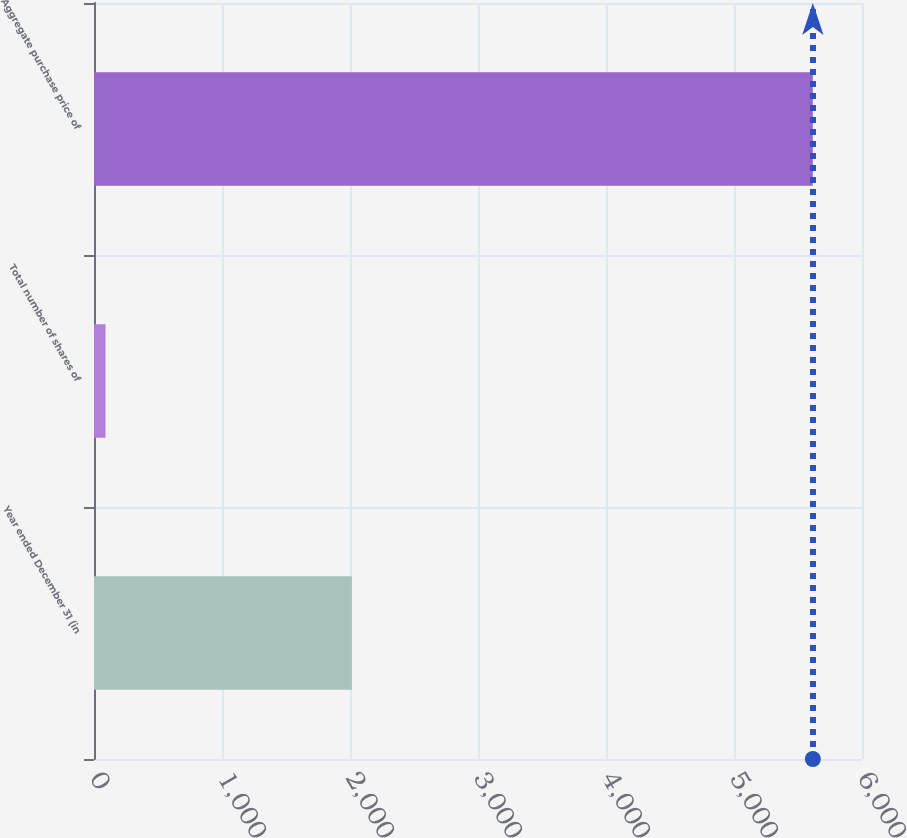Convert chart to OTSL. <chart><loc_0><loc_0><loc_500><loc_500><bar_chart><fcel>Year ended December 31 (in<fcel>Total number of shares of<fcel>Aggregate purchase price of<nl><fcel>2015<fcel>89.8<fcel>5616<nl></chart> 